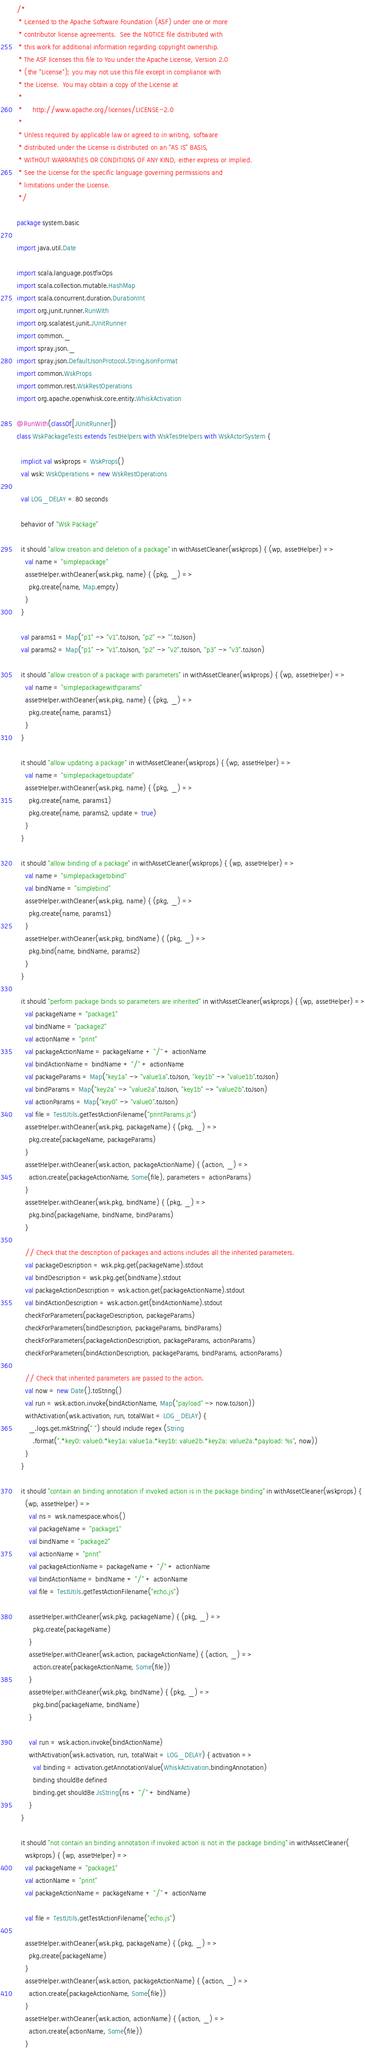Convert code to text. <code><loc_0><loc_0><loc_500><loc_500><_Scala_>/*
 * Licensed to the Apache Software Foundation (ASF) under one or more
 * contributor license agreements.  See the NOTICE file distributed with
 * this work for additional information regarding copyright ownership.
 * The ASF licenses this file to You under the Apache License, Version 2.0
 * (the "License"); you may not use this file except in compliance with
 * the License.  You may obtain a copy of the License at
 *
 *     http://www.apache.org/licenses/LICENSE-2.0
 *
 * Unless required by applicable law or agreed to in writing, software
 * distributed under the License is distributed on an "AS IS" BASIS,
 * WITHOUT WARRANTIES OR CONDITIONS OF ANY KIND, either express or implied.
 * See the License for the specific language governing permissions and
 * limitations under the License.
 */

package system.basic

import java.util.Date

import scala.language.postfixOps
import scala.collection.mutable.HashMap
import scala.concurrent.duration.DurationInt
import org.junit.runner.RunWith
import org.scalatest.junit.JUnitRunner
import common._
import spray.json._
import spray.json.DefaultJsonProtocol.StringJsonFormat
import common.WskProps
import common.rest.WskRestOperations
import org.apache.openwhisk.core.entity.WhiskActivation

@RunWith(classOf[JUnitRunner])
class WskPackageTests extends TestHelpers with WskTestHelpers with WskActorSystem {

  implicit val wskprops = WskProps()
  val wsk: WskOperations = new WskRestOperations

  val LOG_DELAY = 80 seconds

  behavior of "Wsk Package"

  it should "allow creation and deletion of a package" in withAssetCleaner(wskprops) { (wp, assetHelper) =>
    val name = "simplepackage"
    assetHelper.withCleaner(wsk.pkg, name) { (pkg, _) =>
      pkg.create(name, Map.empty)
    }
  }

  val params1 = Map("p1" -> "v1".toJson, "p2" -> "".toJson)
  val params2 = Map("p1" -> "v1".toJson, "p2" -> "v2".toJson, "p3" -> "v3".toJson)

  it should "allow creation of a package with parameters" in withAssetCleaner(wskprops) { (wp, assetHelper) =>
    val name = "simplepackagewithparams"
    assetHelper.withCleaner(wsk.pkg, name) { (pkg, _) =>
      pkg.create(name, params1)
    }
  }

  it should "allow updating a package" in withAssetCleaner(wskprops) { (wp, assetHelper) =>
    val name = "simplepackagetoupdate"
    assetHelper.withCleaner(wsk.pkg, name) { (pkg, _) =>
      pkg.create(name, params1)
      pkg.create(name, params2, update = true)
    }
  }

  it should "allow binding of a package" in withAssetCleaner(wskprops) { (wp, assetHelper) =>
    val name = "simplepackagetobind"
    val bindName = "simplebind"
    assetHelper.withCleaner(wsk.pkg, name) { (pkg, _) =>
      pkg.create(name, params1)
    }
    assetHelper.withCleaner(wsk.pkg, bindName) { (pkg, _) =>
      pkg.bind(name, bindName, params2)
    }
  }

  it should "perform package binds so parameters are inherited" in withAssetCleaner(wskprops) { (wp, assetHelper) =>
    val packageName = "package1"
    val bindName = "package2"
    val actionName = "print"
    val packageActionName = packageName + "/" + actionName
    val bindActionName = bindName + "/" + actionName
    val packageParams = Map("key1a" -> "value1a".toJson, "key1b" -> "value1b".toJson)
    val bindParams = Map("key2a" -> "value2a".toJson, "key1b" -> "value2b".toJson)
    val actionParams = Map("key0" -> "value0".toJson)
    val file = TestUtils.getTestActionFilename("printParams.js")
    assetHelper.withCleaner(wsk.pkg, packageName) { (pkg, _) =>
      pkg.create(packageName, packageParams)
    }
    assetHelper.withCleaner(wsk.action, packageActionName) { (action, _) =>
      action.create(packageActionName, Some(file), parameters = actionParams)
    }
    assetHelper.withCleaner(wsk.pkg, bindName) { (pkg, _) =>
      pkg.bind(packageName, bindName, bindParams)
    }

    // Check that the description of packages and actions includes all the inherited parameters.
    val packageDescription = wsk.pkg.get(packageName).stdout
    val bindDescription = wsk.pkg.get(bindName).stdout
    val packageActionDescription = wsk.action.get(packageActionName).stdout
    val bindActionDescription = wsk.action.get(bindActionName).stdout
    checkForParameters(packageDescription, packageParams)
    checkForParameters(bindDescription, packageParams, bindParams)
    checkForParameters(packageActionDescription, packageParams, actionParams)
    checkForParameters(bindActionDescription, packageParams, bindParams, actionParams)

    // Check that inherited parameters are passed to the action.
    val now = new Date().toString()
    val run = wsk.action.invoke(bindActionName, Map("payload" -> now.toJson))
    withActivation(wsk.activation, run, totalWait = LOG_DELAY) {
      _.logs.get.mkString(" ") should include regex (String
        .format(".*key0: value0.*key1a: value1a.*key1b: value2b.*key2a: value2a.*payload: %s", now))
    }
  }

  it should "contain an binding annotation if invoked action is in the package binding" in withAssetCleaner(wskprops) {
    (wp, assetHelper) =>
      val ns = wsk.namespace.whois()
      val packageName = "package1"
      val bindName = "package2"
      val actionName = "print"
      val packageActionName = packageName + "/" + actionName
      val bindActionName = bindName + "/" + actionName
      val file = TestUtils.getTestActionFilename("echo.js")

      assetHelper.withCleaner(wsk.pkg, packageName) { (pkg, _) =>
        pkg.create(packageName)
      }
      assetHelper.withCleaner(wsk.action, packageActionName) { (action, _) =>
        action.create(packageActionName, Some(file))
      }
      assetHelper.withCleaner(wsk.pkg, bindName) { (pkg, _) =>
        pkg.bind(packageName, bindName)
      }

      val run = wsk.action.invoke(bindActionName)
      withActivation(wsk.activation, run, totalWait = LOG_DELAY) { activation =>
        val binding = activation.getAnnotationValue(WhiskActivation.bindingAnnotation)
        binding shouldBe defined
        binding.get shouldBe JsString(ns + "/" + bindName)
      }
  }

  it should "not contain an binding annotation if invoked action is not in the package binding" in withAssetCleaner(
    wskprops) { (wp, assetHelper) =>
    val packageName = "package1"
    val actionName = "print"
    val packageActionName = packageName + "/" + actionName

    val file = TestUtils.getTestActionFilename("echo.js")

    assetHelper.withCleaner(wsk.pkg, packageName) { (pkg, _) =>
      pkg.create(packageName)
    }
    assetHelper.withCleaner(wsk.action, packageActionName) { (action, _) =>
      action.create(packageActionName, Some(file))
    }
    assetHelper.withCleaner(wsk.action, actionName) { (action, _) =>
      action.create(actionName, Some(file))
    }
</code> 